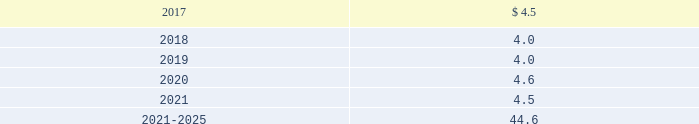Edwards lifesciences corporation notes to consolidated financial statements ( continued ) 12 .
Employee benefit plans ( continued ) equity and debt securities are valued at fair value based on quoted market prices reported on the active markets on which the individual securities are traded .
The insurance contracts are valued at the cash surrender value of the contracts , which is deemed to approximate its fair value .
The following benefit payments , which reflect expected future service , as appropriate , at december 31 , 2016 , are expected to be paid ( in millions ) : .
As of december 31 , 2016 , expected employer contributions for 2017 are $ 6.1 million .
Defined contribution plans the company 2019s employees in the united states and puerto rico are eligible to participate in a qualified defined contribution plan .
In the united states , participants may contribute up to 25% ( 25 % ) of their eligible compensation ( subject to tax code limitation ) to the plan .
Edwards lifesciences matches the first 3% ( 3 % ) of the participant 2019s annual eligible compensation contributed to the plan on a dollar-for-dollar basis .
Edwards lifesciences matches the next 2% ( 2 % ) of the participant 2019s annual eligible compensation to the plan on a 50% ( 50 % ) basis .
In puerto rico , participants may contribute up to 25% ( 25 % ) of their annual compensation ( subject to tax code limitation ) to the plan .
Edwards lifesciences matches the first 4% ( 4 % ) of participant 2019s annual eligible compensation contributed to the plan on a 50% ( 50 % ) basis .
The company also provides a 2% ( 2 % ) profit sharing contribution calculated on eligible earnings for each employee .
Matching contributions relating to edwards lifesciences employees were $ 17.3 million , $ 15.3 million , and $ 12.8 million in 2016 , 2015 , and 2014 , respectively .
The company also has nonqualified deferred compensation plans for a select group of employees .
The plans provide eligible participants the opportunity to defer eligible compensation to future dates specified by the participant with a return based on investment alternatives selected by the participant .
The amount accrued under these nonqualified plans was $ 46.7 million and $ 35.5 million at december 31 , 2016 and 2015 , respectively .
13 .
Common stock treasury stock in july 2014 , the board of directors approved a stock repurchase program authorizing the company to purchase up to $ 750.0 million of the company 2019s common stock .
In november 2016 , the board of directors approved a new stock repurchase program providing for an additional $ 1.0 billion of repurchases of our common stock .
The repurchase programs do not have an expiration date .
Stock repurchased under these programs may be used to offset obligations under the company 2019s employee stock-based benefit programs and stock-based business acquisitions , and will reduce the total shares outstanding .
During 2016 , 2015 , and 2014 , the company repurchased 7.3 million , 2.6 million , and 4.4 million shares , respectively , at an aggregate cost of $ 662.3 million , $ 280.1 million , and $ 300.9 million , respectively , including .
What is the percent change of benefits expected to be paid between 2017 and 2018? 
Computations: ((4.0 - 4.5) / 4.5)
Answer: -0.11111. 